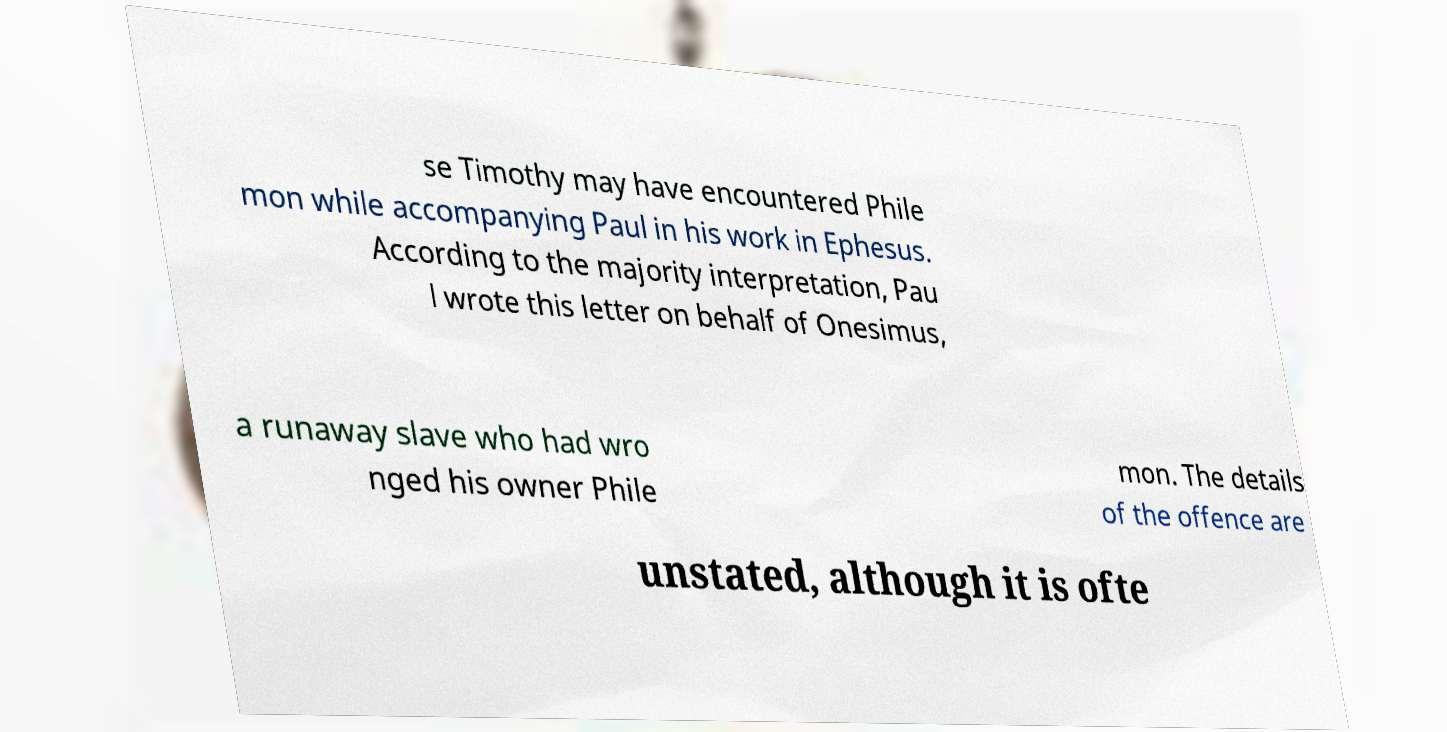Could you assist in decoding the text presented in this image and type it out clearly? se Timothy may have encountered Phile mon while accompanying Paul in his work in Ephesus. According to the majority interpretation, Pau l wrote this letter on behalf of Onesimus, a runaway slave who had wro nged his owner Phile mon. The details of the offence are unstated, although it is ofte 